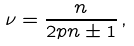<formula> <loc_0><loc_0><loc_500><loc_500>\nu = \frac { n } { 2 p n \pm 1 } \, ,</formula> 